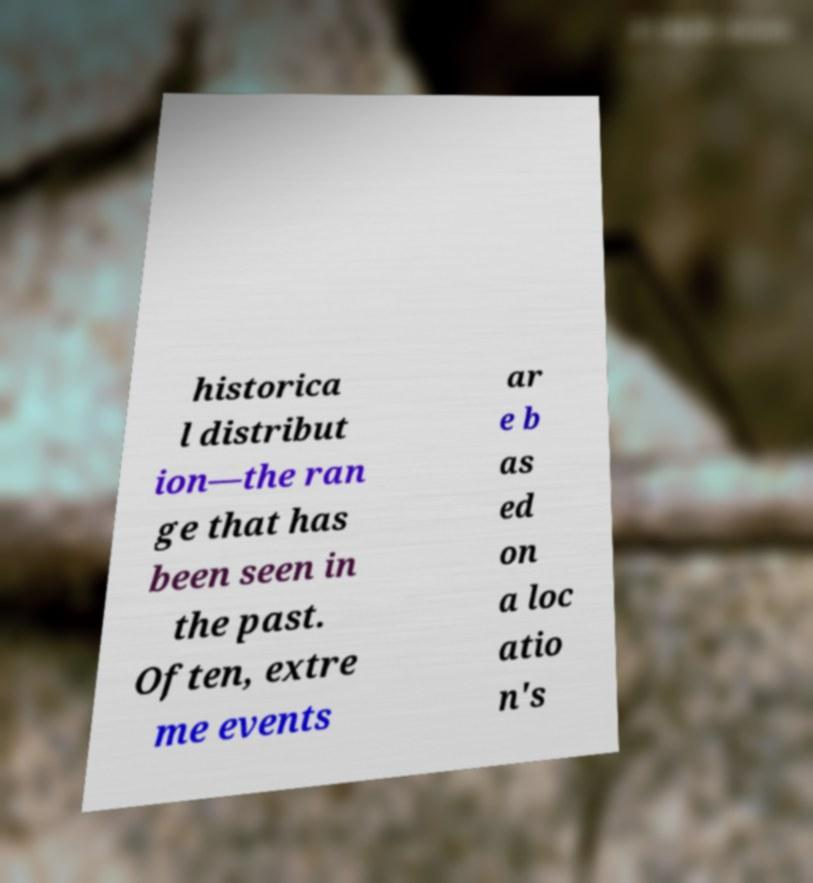Can you read and provide the text displayed in the image?This photo seems to have some interesting text. Can you extract and type it out for me? historica l distribut ion—the ran ge that has been seen in the past. Often, extre me events ar e b as ed on a loc atio n's 